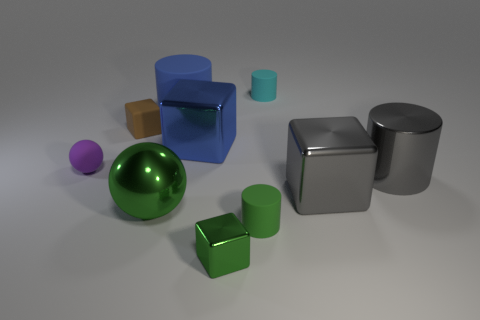Subtract all gray shiny cubes. How many cubes are left? 3 Subtract all cylinders. How many objects are left? 6 Subtract all purple spheres. How many spheres are left? 1 Subtract 2 cylinders. How many cylinders are left? 2 Subtract all metallic things. Subtract all brown matte blocks. How many objects are left? 4 Add 7 gray metal things. How many gray metal things are left? 9 Add 4 large metal cubes. How many large metal cubes exist? 6 Subtract 1 green cylinders. How many objects are left? 9 Subtract all blue spheres. Subtract all cyan cylinders. How many spheres are left? 2 